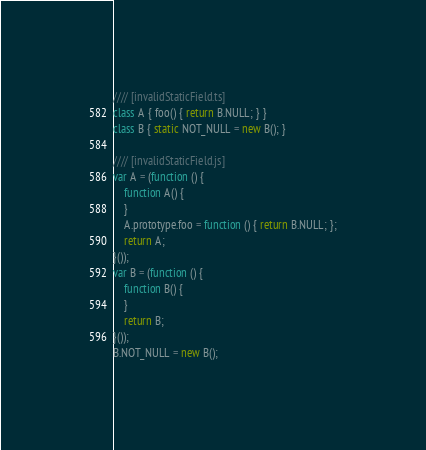<code> <loc_0><loc_0><loc_500><loc_500><_JavaScript_>//// [invalidStaticField.ts]
class A { foo() { return B.NULL; } }
class B { static NOT_NULL = new B(); }

//// [invalidStaticField.js]
var A = (function () {
    function A() {
    }
    A.prototype.foo = function () { return B.NULL; };
    return A;
}());
var B = (function () {
    function B() {
    }
    return B;
}());
B.NOT_NULL = new B();
</code> 